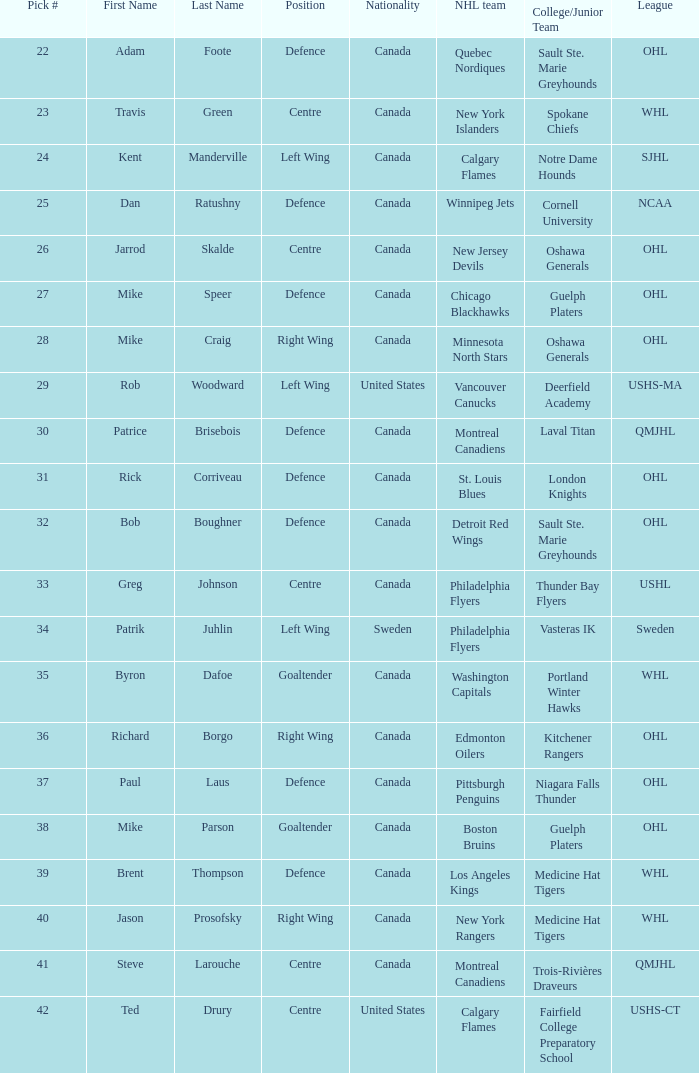What NHL team picked richard borgo? Edmonton Oilers. 